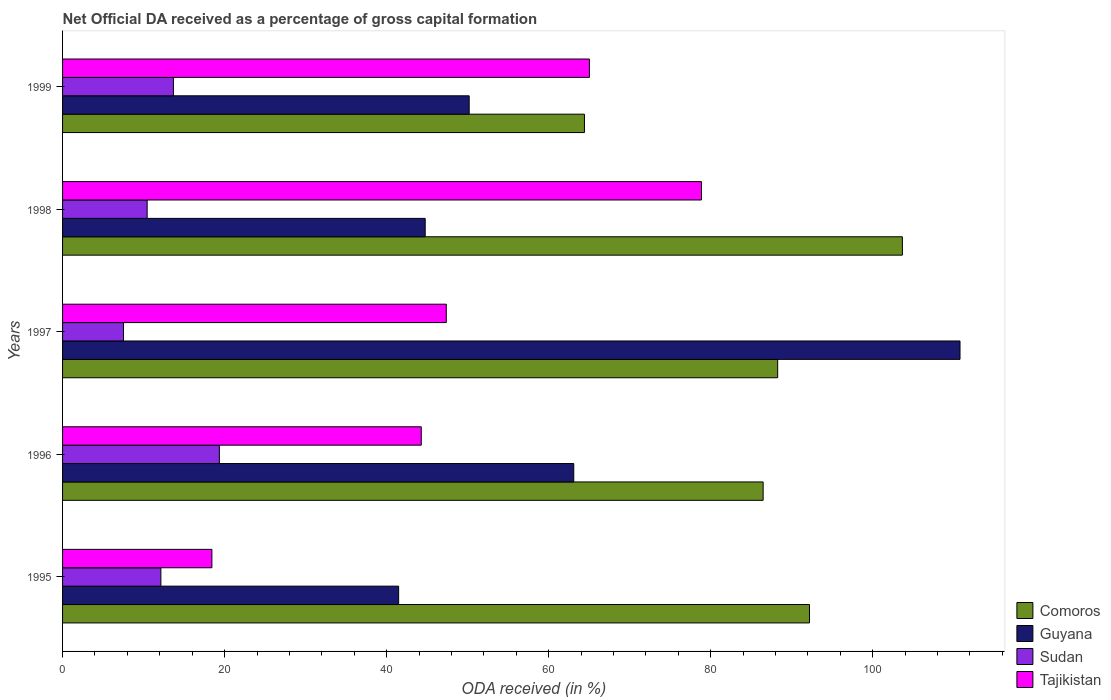How many different coloured bars are there?
Your answer should be compact. 4. How many groups of bars are there?
Keep it short and to the point. 5. How many bars are there on the 3rd tick from the top?
Offer a terse response. 4. How many bars are there on the 4th tick from the bottom?
Ensure brevity in your answer.  4. What is the net ODA received in Comoros in 1999?
Ensure brevity in your answer.  64.42. Across all years, what is the maximum net ODA received in Comoros?
Your answer should be compact. 103.67. Across all years, what is the minimum net ODA received in Comoros?
Keep it short and to the point. 64.42. In which year was the net ODA received in Comoros maximum?
Offer a very short reply. 1998. In which year was the net ODA received in Sudan minimum?
Your response must be concise. 1997. What is the total net ODA received in Sudan in the graph?
Your response must be concise. 63.13. What is the difference between the net ODA received in Tajikistan in 1995 and that in 1996?
Provide a succinct answer. -25.84. What is the difference between the net ODA received in Tajikistan in 1997 and the net ODA received in Comoros in 1998?
Keep it short and to the point. -56.3. What is the average net ODA received in Comoros per year?
Give a very brief answer. 87.01. In the year 1997, what is the difference between the net ODA received in Tajikistan and net ODA received in Guyana?
Give a very brief answer. -63.41. In how many years, is the net ODA received in Tajikistan greater than 52 %?
Your answer should be compact. 2. What is the ratio of the net ODA received in Guyana in 1996 to that in 1998?
Give a very brief answer. 1.41. Is the difference between the net ODA received in Tajikistan in 1995 and 1997 greater than the difference between the net ODA received in Guyana in 1995 and 1997?
Keep it short and to the point. Yes. What is the difference between the highest and the second highest net ODA received in Guyana?
Provide a short and direct response. 47.68. What is the difference between the highest and the lowest net ODA received in Comoros?
Your answer should be very brief. 39.25. In how many years, is the net ODA received in Tajikistan greater than the average net ODA received in Tajikistan taken over all years?
Your answer should be very brief. 2. What does the 4th bar from the top in 1996 represents?
Your answer should be compact. Comoros. What does the 2nd bar from the bottom in 1999 represents?
Give a very brief answer. Guyana. Are all the bars in the graph horizontal?
Give a very brief answer. Yes. Are the values on the major ticks of X-axis written in scientific E-notation?
Provide a short and direct response. No. Does the graph contain any zero values?
Ensure brevity in your answer.  No. How many legend labels are there?
Ensure brevity in your answer.  4. What is the title of the graph?
Provide a succinct answer. Net Official DA received as a percentage of gross capital formation. What is the label or title of the X-axis?
Your answer should be very brief. ODA received (in %). What is the label or title of the Y-axis?
Keep it short and to the point. Years. What is the ODA received (in %) in Comoros in 1995?
Ensure brevity in your answer.  92.2. What is the ODA received (in %) of Guyana in 1995?
Give a very brief answer. 41.48. What is the ODA received (in %) of Sudan in 1995?
Make the answer very short. 12.14. What is the ODA received (in %) of Tajikistan in 1995?
Make the answer very short. 18.43. What is the ODA received (in %) in Comoros in 1996?
Your response must be concise. 86.48. What is the ODA received (in %) in Guyana in 1996?
Provide a short and direct response. 63.1. What is the ODA received (in %) in Sudan in 1996?
Give a very brief answer. 19.35. What is the ODA received (in %) in Tajikistan in 1996?
Provide a short and direct response. 44.28. What is the ODA received (in %) in Comoros in 1997?
Provide a short and direct response. 88.27. What is the ODA received (in %) in Guyana in 1997?
Your answer should be compact. 110.78. What is the ODA received (in %) in Sudan in 1997?
Your answer should be compact. 7.52. What is the ODA received (in %) of Tajikistan in 1997?
Your answer should be very brief. 47.36. What is the ODA received (in %) in Comoros in 1998?
Ensure brevity in your answer.  103.67. What is the ODA received (in %) in Guyana in 1998?
Provide a succinct answer. 44.76. What is the ODA received (in %) in Sudan in 1998?
Provide a short and direct response. 10.44. What is the ODA received (in %) in Tajikistan in 1998?
Offer a terse response. 78.86. What is the ODA received (in %) of Comoros in 1999?
Provide a succinct answer. 64.42. What is the ODA received (in %) in Guyana in 1999?
Your answer should be very brief. 50.19. What is the ODA received (in %) in Sudan in 1999?
Your response must be concise. 13.68. What is the ODA received (in %) of Tajikistan in 1999?
Provide a succinct answer. 65.03. Across all years, what is the maximum ODA received (in %) in Comoros?
Your answer should be very brief. 103.67. Across all years, what is the maximum ODA received (in %) in Guyana?
Your response must be concise. 110.78. Across all years, what is the maximum ODA received (in %) in Sudan?
Your answer should be very brief. 19.35. Across all years, what is the maximum ODA received (in %) of Tajikistan?
Offer a terse response. 78.86. Across all years, what is the minimum ODA received (in %) in Comoros?
Offer a terse response. 64.42. Across all years, what is the minimum ODA received (in %) of Guyana?
Offer a terse response. 41.48. Across all years, what is the minimum ODA received (in %) in Sudan?
Make the answer very short. 7.52. Across all years, what is the minimum ODA received (in %) in Tajikistan?
Your response must be concise. 18.43. What is the total ODA received (in %) in Comoros in the graph?
Offer a terse response. 435.03. What is the total ODA received (in %) of Guyana in the graph?
Give a very brief answer. 310.32. What is the total ODA received (in %) in Sudan in the graph?
Keep it short and to the point. 63.13. What is the total ODA received (in %) in Tajikistan in the graph?
Offer a terse response. 253.97. What is the difference between the ODA received (in %) in Comoros in 1995 and that in 1996?
Your answer should be very brief. 5.72. What is the difference between the ODA received (in %) of Guyana in 1995 and that in 1996?
Make the answer very short. -21.62. What is the difference between the ODA received (in %) of Sudan in 1995 and that in 1996?
Make the answer very short. -7.22. What is the difference between the ODA received (in %) in Tajikistan in 1995 and that in 1996?
Ensure brevity in your answer.  -25.84. What is the difference between the ODA received (in %) of Comoros in 1995 and that in 1997?
Provide a short and direct response. 3.93. What is the difference between the ODA received (in %) in Guyana in 1995 and that in 1997?
Keep it short and to the point. -69.29. What is the difference between the ODA received (in %) of Sudan in 1995 and that in 1997?
Offer a terse response. 4.61. What is the difference between the ODA received (in %) in Tajikistan in 1995 and that in 1997?
Keep it short and to the point. -28.93. What is the difference between the ODA received (in %) in Comoros in 1995 and that in 1998?
Your answer should be compact. -11.47. What is the difference between the ODA received (in %) in Guyana in 1995 and that in 1998?
Your answer should be compact. -3.28. What is the difference between the ODA received (in %) in Sudan in 1995 and that in 1998?
Keep it short and to the point. 1.69. What is the difference between the ODA received (in %) in Tajikistan in 1995 and that in 1998?
Make the answer very short. -60.43. What is the difference between the ODA received (in %) in Comoros in 1995 and that in 1999?
Make the answer very short. 27.78. What is the difference between the ODA received (in %) in Guyana in 1995 and that in 1999?
Give a very brief answer. -8.71. What is the difference between the ODA received (in %) in Sudan in 1995 and that in 1999?
Offer a terse response. -1.55. What is the difference between the ODA received (in %) of Tajikistan in 1995 and that in 1999?
Offer a very short reply. -46.6. What is the difference between the ODA received (in %) of Comoros in 1996 and that in 1997?
Offer a very short reply. -1.79. What is the difference between the ODA received (in %) in Guyana in 1996 and that in 1997?
Offer a terse response. -47.68. What is the difference between the ODA received (in %) of Sudan in 1996 and that in 1997?
Your answer should be very brief. 11.83. What is the difference between the ODA received (in %) of Tajikistan in 1996 and that in 1997?
Your answer should be very brief. -3.09. What is the difference between the ODA received (in %) of Comoros in 1996 and that in 1998?
Offer a terse response. -17.19. What is the difference between the ODA received (in %) of Guyana in 1996 and that in 1998?
Give a very brief answer. 18.34. What is the difference between the ODA received (in %) in Sudan in 1996 and that in 1998?
Offer a very short reply. 8.91. What is the difference between the ODA received (in %) of Tajikistan in 1996 and that in 1998?
Make the answer very short. -34.59. What is the difference between the ODA received (in %) in Comoros in 1996 and that in 1999?
Provide a succinct answer. 22.06. What is the difference between the ODA received (in %) of Guyana in 1996 and that in 1999?
Keep it short and to the point. 12.91. What is the difference between the ODA received (in %) in Sudan in 1996 and that in 1999?
Make the answer very short. 5.67. What is the difference between the ODA received (in %) in Tajikistan in 1996 and that in 1999?
Your answer should be very brief. -20.76. What is the difference between the ODA received (in %) in Comoros in 1997 and that in 1998?
Your answer should be very brief. -15.4. What is the difference between the ODA received (in %) in Guyana in 1997 and that in 1998?
Keep it short and to the point. 66.01. What is the difference between the ODA received (in %) in Sudan in 1997 and that in 1998?
Your response must be concise. -2.92. What is the difference between the ODA received (in %) of Tajikistan in 1997 and that in 1998?
Your response must be concise. -31.5. What is the difference between the ODA received (in %) of Comoros in 1997 and that in 1999?
Your answer should be very brief. 23.85. What is the difference between the ODA received (in %) of Guyana in 1997 and that in 1999?
Give a very brief answer. 60.59. What is the difference between the ODA received (in %) of Sudan in 1997 and that in 1999?
Your answer should be compact. -6.16. What is the difference between the ODA received (in %) in Tajikistan in 1997 and that in 1999?
Provide a short and direct response. -17.67. What is the difference between the ODA received (in %) of Comoros in 1998 and that in 1999?
Offer a very short reply. 39.25. What is the difference between the ODA received (in %) in Guyana in 1998 and that in 1999?
Offer a very short reply. -5.43. What is the difference between the ODA received (in %) in Sudan in 1998 and that in 1999?
Give a very brief answer. -3.24. What is the difference between the ODA received (in %) of Tajikistan in 1998 and that in 1999?
Make the answer very short. 13.83. What is the difference between the ODA received (in %) of Comoros in 1995 and the ODA received (in %) of Guyana in 1996?
Make the answer very short. 29.1. What is the difference between the ODA received (in %) of Comoros in 1995 and the ODA received (in %) of Sudan in 1996?
Give a very brief answer. 72.84. What is the difference between the ODA received (in %) in Comoros in 1995 and the ODA received (in %) in Tajikistan in 1996?
Your response must be concise. 47.92. What is the difference between the ODA received (in %) of Guyana in 1995 and the ODA received (in %) of Sudan in 1996?
Provide a succinct answer. 22.13. What is the difference between the ODA received (in %) of Guyana in 1995 and the ODA received (in %) of Tajikistan in 1996?
Ensure brevity in your answer.  -2.79. What is the difference between the ODA received (in %) of Sudan in 1995 and the ODA received (in %) of Tajikistan in 1996?
Provide a succinct answer. -32.14. What is the difference between the ODA received (in %) of Comoros in 1995 and the ODA received (in %) of Guyana in 1997?
Provide a short and direct response. -18.58. What is the difference between the ODA received (in %) in Comoros in 1995 and the ODA received (in %) in Sudan in 1997?
Ensure brevity in your answer.  84.68. What is the difference between the ODA received (in %) in Comoros in 1995 and the ODA received (in %) in Tajikistan in 1997?
Your answer should be compact. 44.83. What is the difference between the ODA received (in %) in Guyana in 1995 and the ODA received (in %) in Sudan in 1997?
Your answer should be compact. 33.96. What is the difference between the ODA received (in %) in Guyana in 1995 and the ODA received (in %) in Tajikistan in 1997?
Provide a short and direct response. -5.88. What is the difference between the ODA received (in %) of Sudan in 1995 and the ODA received (in %) of Tajikistan in 1997?
Give a very brief answer. -35.23. What is the difference between the ODA received (in %) in Comoros in 1995 and the ODA received (in %) in Guyana in 1998?
Your response must be concise. 47.44. What is the difference between the ODA received (in %) of Comoros in 1995 and the ODA received (in %) of Sudan in 1998?
Your answer should be compact. 81.76. What is the difference between the ODA received (in %) of Comoros in 1995 and the ODA received (in %) of Tajikistan in 1998?
Keep it short and to the point. 13.34. What is the difference between the ODA received (in %) of Guyana in 1995 and the ODA received (in %) of Sudan in 1998?
Ensure brevity in your answer.  31.04. What is the difference between the ODA received (in %) of Guyana in 1995 and the ODA received (in %) of Tajikistan in 1998?
Give a very brief answer. -37.38. What is the difference between the ODA received (in %) of Sudan in 1995 and the ODA received (in %) of Tajikistan in 1998?
Your response must be concise. -66.73. What is the difference between the ODA received (in %) of Comoros in 1995 and the ODA received (in %) of Guyana in 1999?
Your response must be concise. 42.01. What is the difference between the ODA received (in %) in Comoros in 1995 and the ODA received (in %) in Sudan in 1999?
Provide a short and direct response. 78.52. What is the difference between the ODA received (in %) of Comoros in 1995 and the ODA received (in %) of Tajikistan in 1999?
Ensure brevity in your answer.  27.16. What is the difference between the ODA received (in %) in Guyana in 1995 and the ODA received (in %) in Sudan in 1999?
Your answer should be very brief. 27.8. What is the difference between the ODA received (in %) in Guyana in 1995 and the ODA received (in %) in Tajikistan in 1999?
Your answer should be compact. -23.55. What is the difference between the ODA received (in %) of Sudan in 1995 and the ODA received (in %) of Tajikistan in 1999?
Ensure brevity in your answer.  -52.9. What is the difference between the ODA received (in %) of Comoros in 1996 and the ODA received (in %) of Guyana in 1997?
Your answer should be very brief. -24.3. What is the difference between the ODA received (in %) of Comoros in 1996 and the ODA received (in %) of Sudan in 1997?
Ensure brevity in your answer.  78.96. What is the difference between the ODA received (in %) in Comoros in 1996 and the ODA received (in %) in Tajikistan in 1997?
Give a very brief answer. 39.11. What is the difference between the ODA received (in %) of Guyana in 1996 and the ODA received (in %) of Sudan in 1997?
Provide a short and direct response. 55.58. What is the difference between the ODA received (in %) in Guyana in 1996 and the ODA received (in %) in Tajikistan in 1997?
Provide a short and direct response. 15.74. What is the difference between the ODA received (in %) of Sudan in 1996 and the ODA received (in %) of Tajikistan in 1997?
Make the answer very short. -28.01. What is the difference between the ODA received (in %) of Comoros in 1996 and the ODA received (in %) of Guyana in 1998?
Your answer should be compact. 41.71. What is the difference between the ODA received (in %) in Comoros in 1996 and the ODA received (in %) in Sudan in 1998?
Make the answer very short. 76.03. What is the difference between the ODA received (in %) of Comoros in 1996 and the ODA received (in %) of Tajikistan in 1998?
Offer a terse response. 7.61. What is the difference between the ODA received (in %) of Guyana in 1996 and the ODA received (in %) of Sudan in 1998?
Make the answer very short. 52.66. What is the difference between the ODA received (in %) of Guyana in 1996 and the ODA received (in %) of Tajikistan in 1998?
Provide a short and direct response. -15.76. What is the difference between the ODA received (in %) in Sudan in 1996 and the ODA received (in %) in Tajikistan in 1998?
Give a very brief answer. -59.51. What is the difference between the ODA received (in %) of Comoros in 1996 and the ODA received (in %) of Guyana in 1999?
Your response must be concise. 36.28. What is the difference between the ODA received (in %) in Comoros in 1996 and the ODA received (in %) in Sudan in 1999?
Provide a succinct answer. 72.79. What is the difference between the ODA received (in %) in Comoros in 1996 and the ODA received (in %) in Tajikistan in 1999?
Provide a short and direct response. 21.44. What is the difference between the ODA received (in %) of Guyana in 1996 and the ODA received (in %) of Sudan in 1999?
Your answer should be compact. 49.42. What is the difference between the ODA received (in %) in Guyana in 1996 and the ODA received (in %) in Tajikistan in 1999?
Your response must be concise. -1.93. What is the difference between the ODA received (in %) in Sudan in 1996 and the ODA received (in %) in Tajikistan in 1999?
Provide a succinct answer. -45.68. What is the difference between the ODA received (in %) of Comoros in 1997 and the ODA received (in %) of Guyana in 1998?
Give a very brief answer. 43.51. What is the difference between the ODA received (in %) in Comoros in 1997 and the ODA received (in %) in Sudan in 1998?
Keep it short and to the point. 77.83. What is the difference between the ODA received (in %) of Comoros in 1997 and the ODA received (in %) of Tajikistan in 1998?
Your answer should be very brief. 9.41. What is the difference between the ODA received (in %) of Guyana in 1997 and the ODA received (in %) of Sudan in 1998?
Your answer should be very brief. 100.34. What is the difference between the ODA received (in %) in Guyana in 1997 and the ODA received (in %) in Tajikistan in 1998?
Make the answer very short. 31.92. What is the difference between the ODA received (in %) of Sudan in 1997 and the ODA received (in %) of Tajikistan in 1998?
Offer a very short reply. -71.34. What is the difference between the ODA received (in %) in Comoros in 1997 and the ODA received (in %) in Guyana in 1999?
Keep it short and to the point. 38.08. What is the difference between the ODA received (in %) in Comoros in 1997 and the ODA received (in %) in Sudan in 1999?
Offer a very short reply. 74.59. What is the difference between the ODA received (in %) in Comoros in 1997 and the ODA received (in %) in Tajikistan in 1999?
Give a very brief answer. 23.24. What is the difference between the ODA received (in %) of Guyana in 1997 and the ODA received (in %) of Sudan in 1999?
Make the answer very short. 97.09. What is the difference between the ODA received (in %) in Guyana in 1997 and the ODA received (in %) in Tajikistan in 1999?
Offer a terse response. 45.74. What is the difference between the ODA received (in %) in Sudan in 1997 and the ODA received (in %) in Tajikistan in 1999?
Your answer should be very brief. -57.51. What is the difference between the ODA received (in %) in Comoros in 1998 and the ODA received (in %) in Guyana in 1999?
Offer a terse response. 53.47. What is the difference between the ODA received (in %) in Comoros in 1998 and the ODA received (in %) in Sudan in 1999?
Offer a very short reply. 89.98. What is the difference between the ODA received (in %) in Comoros in 1998 and the ODA received (in %) in Tajikistan in 1999?
Offer a terse response. 38.63. What is the difference between the ODA received (in %) in Guyana in 1998 and the ODA received (in %) in Sudan in 1999?
Your answer should be compact. 31.08. What is the difference between the ODA received (in %) of Guyana in 1998 and the ODA received (in %) of Tajikistan in 1999?
Provide a short and direct response. -20.27. What is the difference between the ODA received (in %) of Sudan in 1998 and the ODA received (in %) of Tajikistan in 1999?
Offer a terse response. -54.59. What is the average ODA received (in %) in Comoros per year?
Give a very brief answer. 87.01. What is the average ODA received (in %) of Guyana per year?
Offer a very short reply. 62.06. What is the average ODA received (in %) of Sudan per year?
Give a very brief answer. 12.63. What is the average ODA received (in %) of Tajikistan per year?
Make the answer very short. 50.79. In the year 1995, what is the difference between the ODA received (in %) in Comoros and ODA received (in %) in Guyana?
Your answer should be very brief. 50.71. In the year 1995, what is the difference between the ODA received (in %) of Comoros and ODA received (in %) of Sudan?
Provide a succinct answer. 80.06. In the year 1995, what is the difference between the ODA received (in %) of Comoros and ODA received (in %) of Tajikistan?
Give a very brief answer. 73.77. In the year 1995, what is the difference between the ODA received (in %) of Guyana and ODA received (in %) of Sudan?
Your answer should be compact. 29.35. In the year 1995, what is the difference between the ODA received (in %) of Guyana and ODA received (in %) of Tajikistan?
Offer a very short reply. 23.05. In the year 1995, what is the difference between the ODA received (in %) of Sudan and ODA received (in %) of Tajikistan?
Give a very brief answer. -6.3. In the year 1996, what is the difference between the ODA received (in %) in Comoros and ODA received (in %) in Guyana?
Make the answer very short. 23.38. In the year 1996, what is the difference between the ODA received (in %) in Comoros and ODA received (in %) in Sudan?
Make the answer very short. 67.12. In the year 1996, what is the difference between the ODA received (in %) of Comoros and ODA received (in %) of Tajikistan?
Ensure brevity in your answer.  42.2. In the year 1996, what is the difference between the ODA received (in %) of Guyana and ODA received (in %) of Sudan?
Offer a terse response. 43.75. In the year 1996, what is the difference between the ODA received (in %) in Guyana and ODA received (in %) in Tajikistan?
Make the answer very short. 18.82. In the year 1996, what is the difference between the ODA received (in %) in Sudan and ODA received (in %) in Tajikistan?
Keep it short and to the point. -24.92. In the year 1997, what is the difference between the ODA received (in %) of Comoros and ODA received (in %) of Guyana?
Your response must be concise. -22.51. In the year 1997, what is the difference between the ODA received (in %) of Comoros and ODA received (in %) of Sudan?
Ensure brevity in your answer.  80.75. In the year 1997, what is the difference between the ODA received (in %) of Comoros and ODA received (in %) of Tajikistan?
Your answer should be compact. 40.91. In the year 1997, what is the difference between the ODA received (in %) of Guyana and ODA received (in %) of Sudan?
Give a very brief answer. 103.26. In the year 1997, what is the difference between the ODA received (in %) in Guyana and ODA received (in %) in Tajikistan?
Provide a succinct answer. 63.41. In the year 1997, what is the difference between the ODA received (in %) of Sudan and ODA received (in %) of Tajikistan?
Offer a very short reply. -39.84. In the year 1998, what is the difference between the ODA received (in %) in Comoros and ODA received (in %) in Guyana?
Offer a terse response. 58.9. In the year 1998, what is the difference between the ODA received (in %) of Comoros and ODA received (in %) of Sudan?
Make the answer very short. 93.22. In the year 1998, what is the difference between the ODA received (in %) of Comoros and ODA received (in %) of Tajikistan?
Provide a succinct answer. 24.8. In the year 1998, what is the difference between the ODA received (in %) of Guyana and ODA received (in %) of Sudan?
Your answer should be very brief. 34.32. In the year 1998, what is the difference between the ODA received (in %) in Guyana and ODA received (in %) in Tajikistan?
Provide a short and direct response. -34.1. In the year 1998, what is the difference between the ODA received (in %) in Sudan and ODA received (in %) in Tajikistan?
Offer a terse response. -68.42. In the year 1999, what is the difference between the ODA received (in %) in Comoros and ODA received (in %) in Guyana?
Provide a succinct answer. 14.23. In the year 1999, what is the difference between the ODA received (in %) in Comoros and ODA received (in %) in Sudan?
Offer a terse response. 50.74. In the year 1999, what is the difference between the ODA received (in %) of Comoros and ODA received (in %) of Tajikistan?
Provide a succinct answer. -0.62. In the year 1999, what is the difference between the ODA received (in %) in Guyana and ODA received (in %) in Sudan?
Keep it short and to the point. 36.51. In the year 1999, what is the difference between the ODA received (in %) in Guyana and ODA received (in %) in Tajikistan?
Give a very brief answer. -14.84. In the year 1999, what is the difference between the ODA received (in %) of Sudan and ODA received (in %) of Tajikistan?
Ensure brevity in your answer.  -51.35. What is the ratio of the ODA received (in %) of Comoros in 1995 to that in 1996?
Give a very brief answer. 1.07. What is the ratio of the ODA received (in %) in Guyana in 1995 to that in 1996?
Your response must be concise. 0.66. What is the ratio of the ODA received (in %) of Sudan in 1995 to that in 1996?
Provide a short and direct response. 0.63. What is the ratio of the ODA received (in %) in Tajikistan in 1995 to that in 1996?
Offer a terse response. 0.42. What is the ratio of the ODA received (in %) in Comoros in 1995 to that in 1997?
Offer a terse response. 1.04. What is the ratio of the ODA received (in %) of Guyana in 1995 to that in 1997?
Offer a terse response. 0.37. What is the ratio of the ODA received (in %) in Sudan in 1995 to that in 1997?
Your answer should be very brief. 1.61. What is the ratio of the ODA received (in %) in Tajikistan in 1995 to that in 1997?
Your answer should be compact. 0.39. What is the ratio of the ODA received (in %) of Comoros in 1995 to that in 1998?
Ensure brevity in your answer.  0.89. What is the ratio of the ODA received (in %) of Guyana in 1995 to that in 1998?
Make the answer very short. 0.93. What is the ratio of the ODA received (in %) of Sudan in 1995 to that in 1998?
Provide a short and direct response. 1.16. What is the ratio of the ODA received (in %) in Tajikistan in 1995 to that in 1998?
Offer a very short reply. 0.23. What is the ratio of the ODA received (in %) in Comoros in 1995 to that in 1999?
Make the answer very short. 1.43. What is the ratio of the ODA received (in %) of Guyana in 1995 to that in 1999?
Offer a terse response. 0.83. What is the ratio of the ODA received (in %) of Sudan in 1995 to that in 1999?
Offer a terse response. 0.89. What is the ratio of the ODA received (in %) in Tajikistan in 1995 to that in 1999?
Make the answer very short. 0.28. What is the ratio of the ODA received (in %) of Comoros in 1996 to that in 1997?
Provide a short and direct response. 0.98. What is the ratio of the ODA received (in %) in Guyana in 1996 to that in 1997?
Keep it short and to the point. 0.57. What is the ratio of the ODA received (in %) of Sudan in 1996 to that in 1997?
Your answer should be very brief. 2.57. What is the ratio of the ODA received (in %) in Tajikistan in 1996 to that in 1997?
Offer a terse response. 0.93. What is the ratio of the ODA received (in %) of Comoros in 1996 to that in 1998?
Offer a terse response. 0.83. What is the ratio of the ODA received (in %) in Guyana in 1996 to that in 1998?
Offer a terse response. 1.41. What is the ratio of the ODA received (in %) of Sudan in 1996 to that in 1998?
Provide a succinct answer. 1.85. What is the ratio of the ODA received (in %) of Tajikistan in 1996 to that in 1998?
Your response must be concise. 0.56. What is the ratio of the ODA received (in %) of Comoros in 1996 to that in 1999?
Give a very brief answer. 1.34. What is the ratio of the ODA received (in %) of Guyana in 1996 to that in 1999?
Make the answer very short. 1.26. What is the ratio of the ODA received (in %) of Sudan in 1996 to that in 1999?
Your answer should be compact. 1.41. What is the ratio of the ODA received (in %) of Tajikistan in 1996 to that in 1999?
Ensure brevity in your answer.  0.68. What is the ratio of the ODA received (in %) in Comoros in 1997 to that in 1998?
Your answer should be very brief. 0.85. What is the ratio of the ODA received (in %) of Guyana in 1997 to that in 1998?
Give a very brief answer. 2.47. What is the ratio of the ODA received (in %) of Sudan in 1997 to that in 1998?
Your response must be concise. 0.72. What is the ratio of the ODA received (in %) of Tajikistan in 1997 to that in 1998?
Keep it short and to the point. 0.6. What is the ratio of the ODA received (in %) of Comoros in 1997 to that in 1999?
Provide a short and direct response. 1.37. What is the ratio of the ODA received (in %) in Guyana in 1997 to that in 1999?
Offer a terse response. 2.21. What is the ratio of the ODA received (in %) in Sudan in 1997 to that in 1999?
Provide a short and direct response. 0.55. What is the ratio of the ODA received (in %) of Tajikistan in 1997 to that in 1999?
Your answer should be very brief. 0.73. What is the ratio of the ODA received (in %) of Comoros in 1998 to that in 1999?
Offer a terse response. 1.61. What is the ratio of the ODA received (in %) of Guyana in 1998 to that in 1999?
Offer a terse response. 0.89. What is the ratio of the ODA received (in %) of Sudan in 1998 to that in 1999?
Your answer should be compact. 0.76. What is the ratio of the ODA received (in %) of Tajikistan in 1998 to that in 1999?
Give a very brief answer. 1.21. What is the difference between the highest and the second highest ODA received (in %) of Comoros?
Offer a very short reply. 11.47. What is the difference between the highest and the second highest ODA received (in %) of Guyana?
Offer a terse response. 47.68. What is the difference between the highest and the second highest ODA received (in %) in Sudan?
Ensure brevity in your answer.  5.67. What is the difference between the highest and the second highest ODA received (in %) in Tajikistan?
Give a very brief answer. 13.83. What is the difference between the highest and the lowest ODA received (in %) in Comoros?
Ensure brevity in your answer.  39.25. What is the difference between the highest and the lowest ODA received (in %) of Guyana?
Your answer should be very brief. 69.29. What is the difference between the highest and the lowest ODA received (in %) in Sudan?
Provide a succinct answer. 11.83. What is the difference between the highest and the lowest ODA received (in %) of Tajikistan?
Keep it short and to the point. 60.43. 